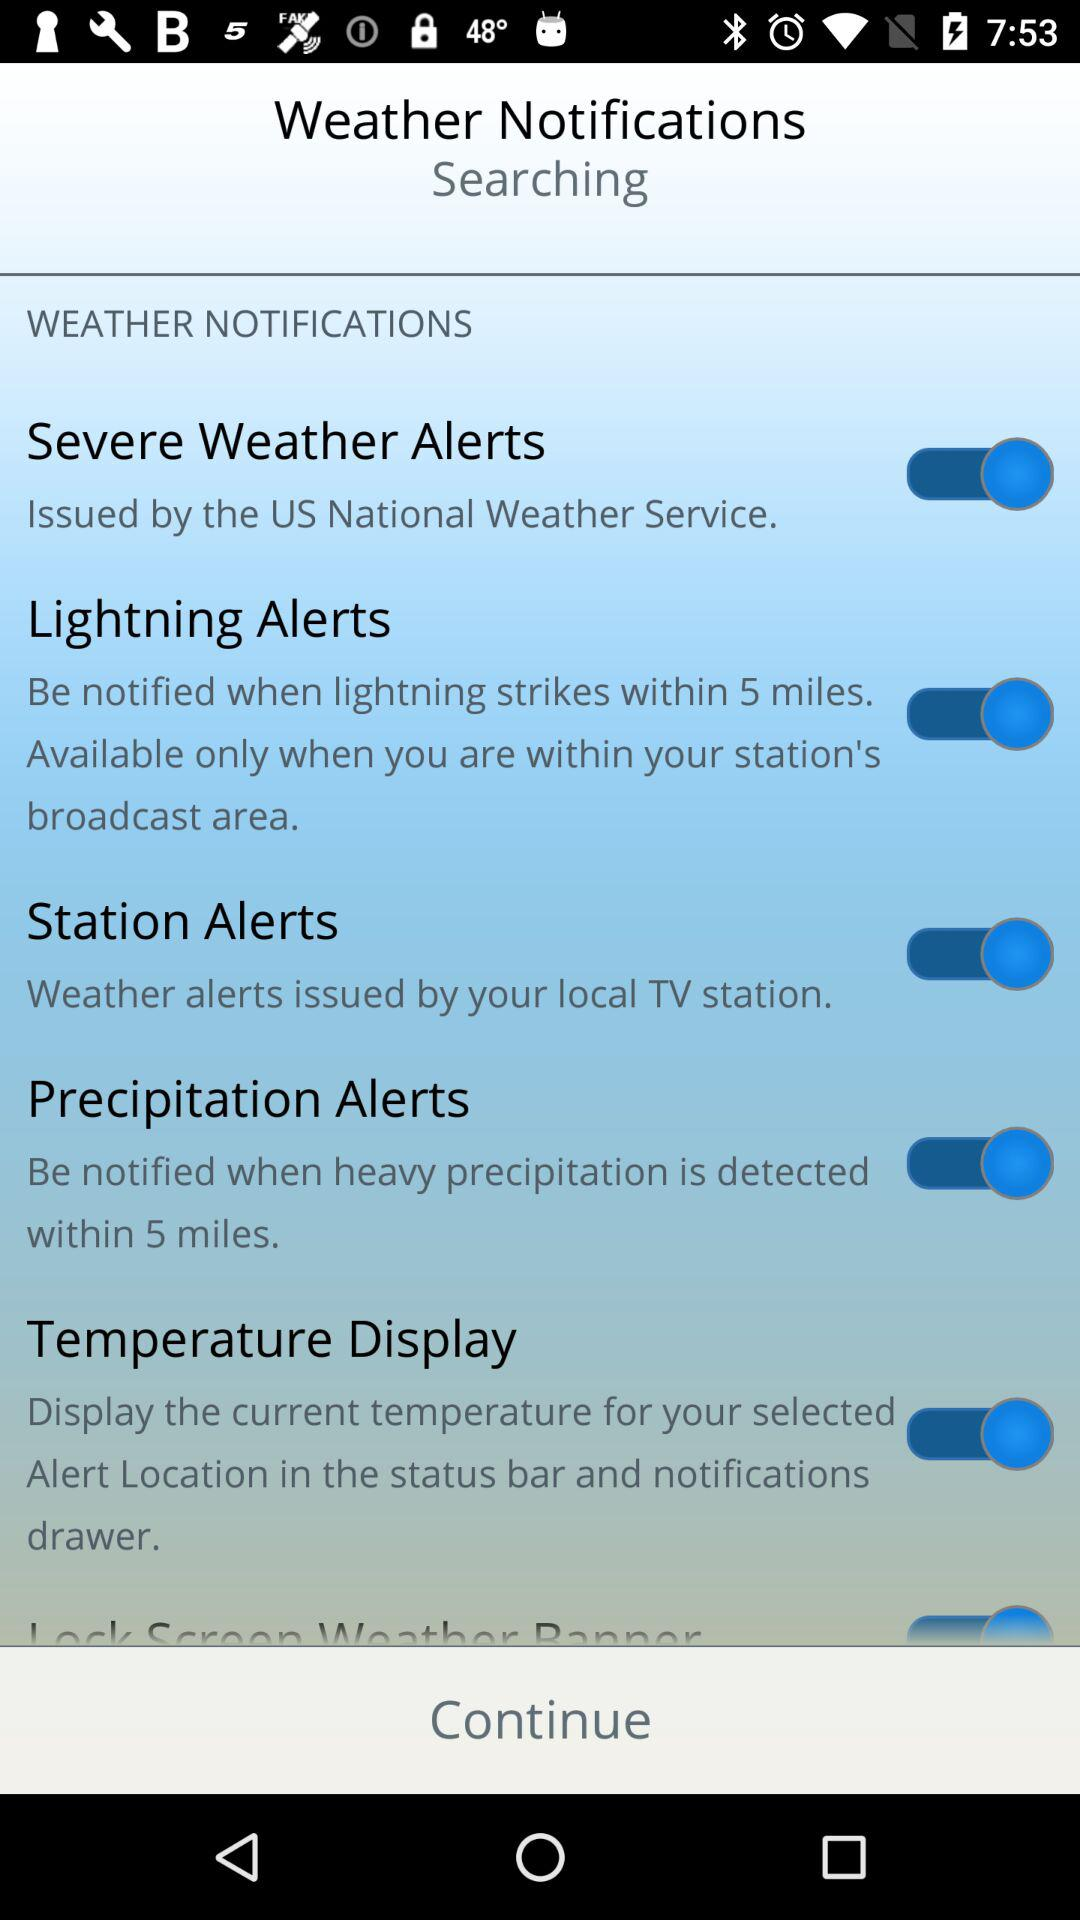Where will the current temperature for the selected alert location be displayed? The current temperature for the selected alert location will be displayed in the status bar and notifications drawer. 